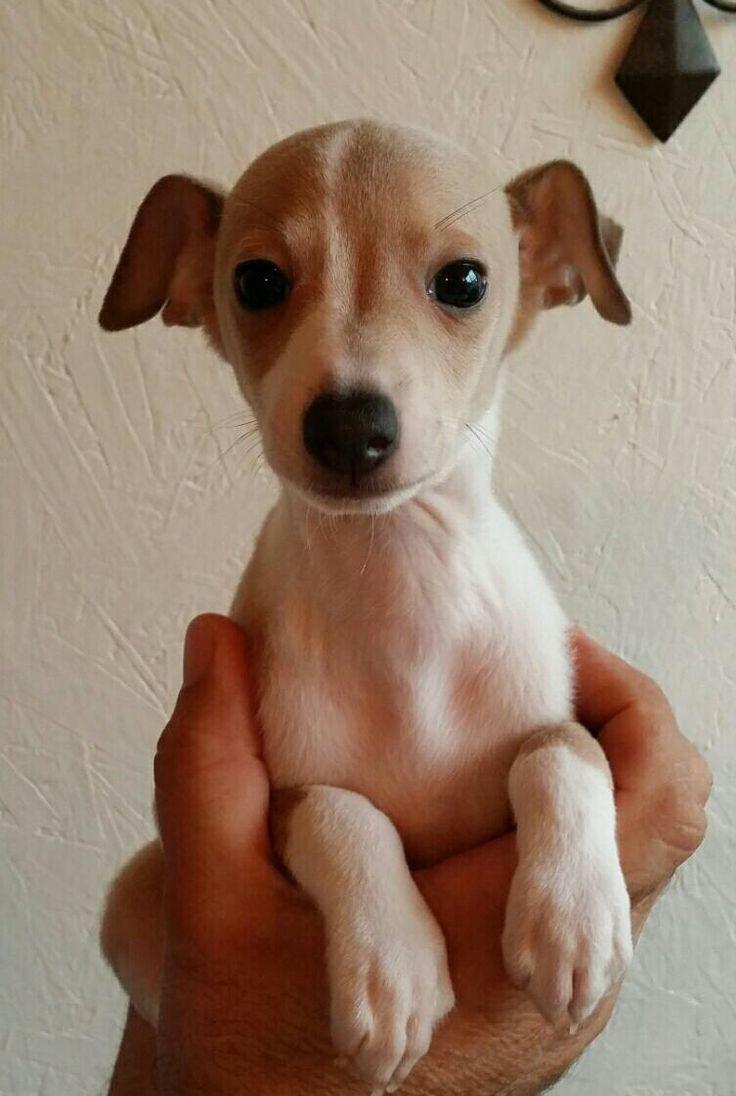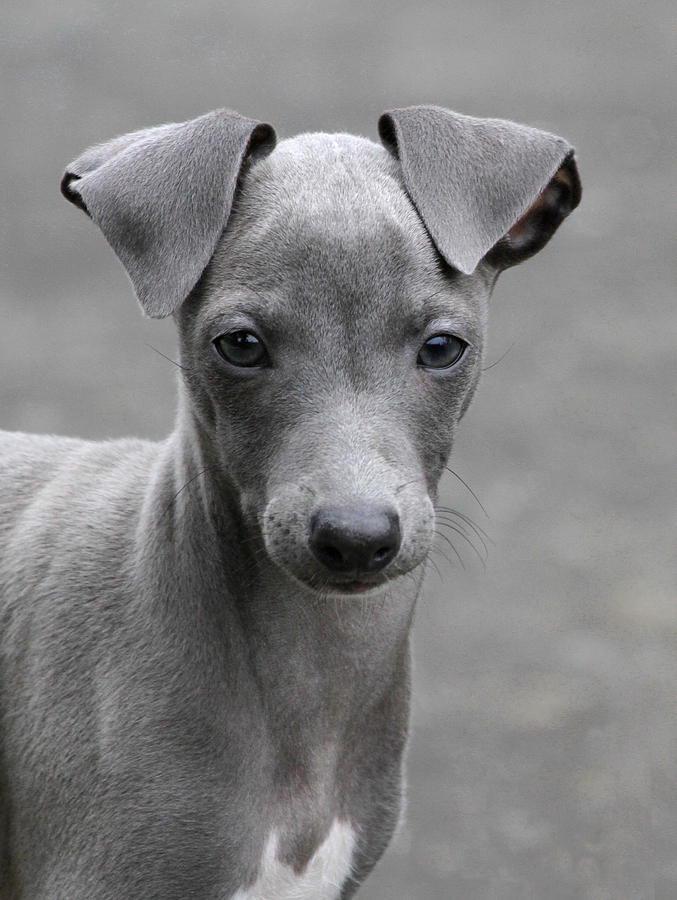The first image is the image on the left, the second image is the image on the right. Examine the images to the left and right. Is the description "There are more dogs in the right image than in the left." accurate? Answer yes or no. No. 